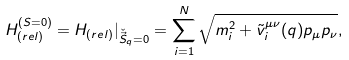<formula> <loc_0><loc_0><loc_500><loc_500>H _ { ( r e l ) } ^ { ( S = 0 ) } = H _ { ( r e l ) } { | } _ { { \check { \vec { S } } } _ { q } = 0 } = \sum _ { i = 1 } ^ { N } \sqrt { m _ { i } ^ { 2 } + { \tilde { v } } _ { i } ^ { \mu \nu } ( q ) p _ { \mu } p _ { \nu } } ,</formula> 